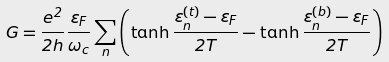Convert formula to latex. <formula><loc_0><loc_0><loc_500><loc_500>G = \frac { e ^ { 2 } } { 2 h } \frac { \varepsilon _ { F } } { \hbar { \omega } _ { c } } \sum _ { n } \left ( \tanh { \frac { \varepsilon _ { n } ^ { ( t ) } - \varepsilon _ { F } } { 2 T } } - \tanh { \frac { \varepsilon _ { n } ^ { ( b ) } - \varepsilon _ { F } } { 2 T } } \right )</formula> 